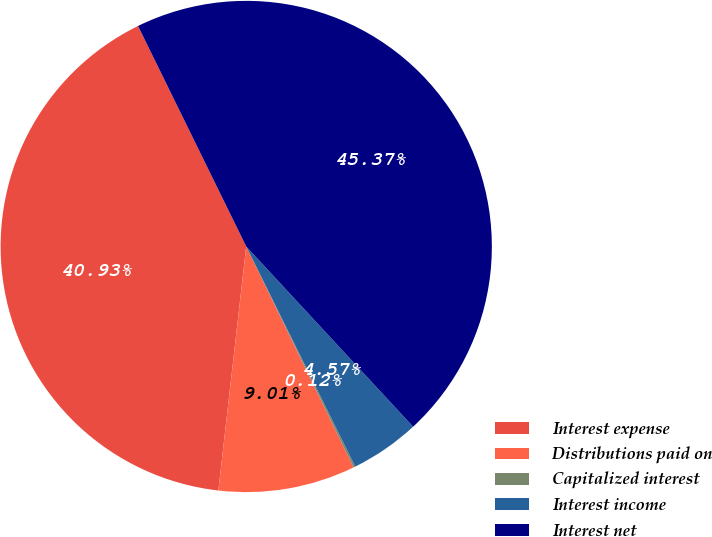Convert chart. <chart><loc_0><loc_0><loc_500><loc_500><pie_chart><fcel>Interest expense<fcel>Distributions paid on<fcel>Capitalized interest<fcel>Interest income<fcel>Interest net<nl><fcel>40.93%<fcel>9.01%<fcel>0.12%<fcel>4.57%<fcel>45.37%<nl></chart> 